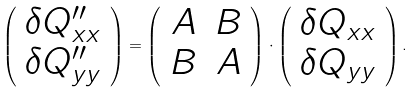<formula> <loc_0><loc_0><loc_500><loc_500>\left ( \begin{array} { c } \delta Q ^ { \prime \prime } _ { x x } \\ \delta Q ^ { \prime \prime } _ { y y } \end{array} \right ) = \left ( \begin{array} { c c } A & B \\ B & A \end{array} \right ) \cdot \left ( \begin{array} { c } \delta Q _ { x x } \\ \delta Q _ { y y } \end{array} \right ) .</formula> 